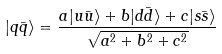Convert formula to latex. <formula><loc_0><loc_0><loc_500><loc_500>| q \bar { q } \rangle = \frac { a | u \bar { u } \rangle + b | d \bar { d } \rangle + c | s \bar { s } \rangle } { \sqrt { a ^ { 2 } + b ^ { 2 } + c ^ { 2 } } }</formula> 